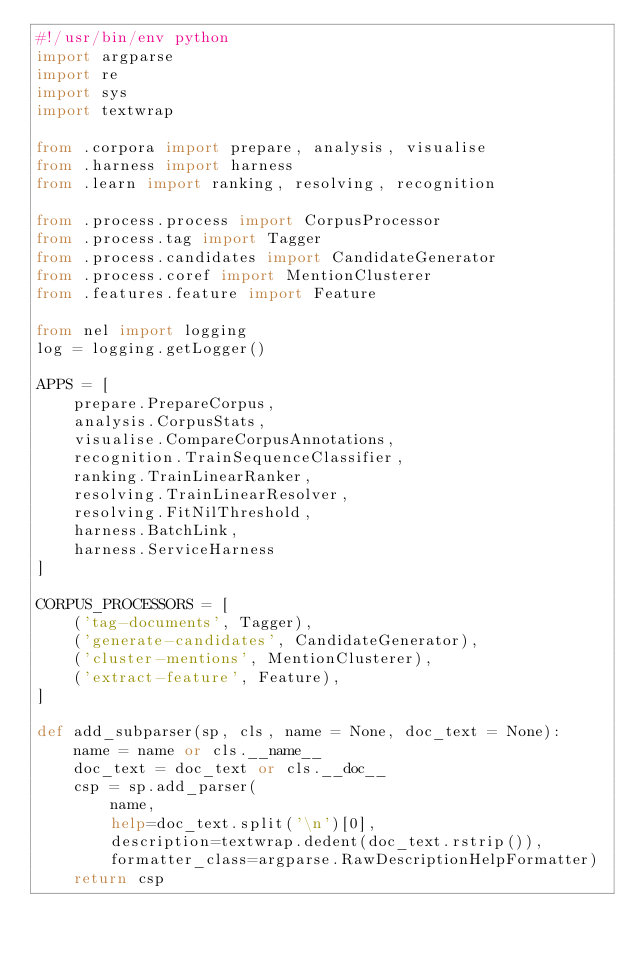<code> <loc_0><loc_0><loc_500><loc_500><_Python_>#!/usr/bin/env python
import argparse
import re
import sys
import textwrap

from .corpora import prepare, analysis, visualise
from .harness import harness
from .learn import ranking, resolving, recognition

from .process.process import CorpusProcessor
from .process.tag import Tagger
from .process.candidates import CandidateGenerator
from .process.coref import MentionClusterer
from .features.feature import Feature

from nel import logging
log = logging.getLogger()

APPS = [
    prepare.PrepareCorpus,
    analysis.CorpusStats,
    visualise.CompareCorpusAnnotations,
    recognition.TrainSequenceClassifier,
    ranking.TrainLinearRanker,
    resolving.TrainLinearResolver,
    resolving.FitNilThreshold,
    harness.BatchLink,
    harness.ServiceHarness
]

CORPUS_PROCESSORS = [
    ('tag-documents', Tagger),
    ('generate-candidates', CandidateGenerator),
    ('cluster-mentions', MentionClusterer),
    ('extract-feature', Feature),
]

def add_subparser(sp, cls, name = None, doc_text = None):
    name = name or cls.__name__
    doc_text = doc_text or cls.__doc__
    csp = sp.add_parser(
        name,
        help=doc_text.split('\n')[0],
        description=textwrap.dedent(doc_text.rstrip()),
        formatter_class=argparse.RawDescriptionHelpFormatter)
    return csp
</code> 